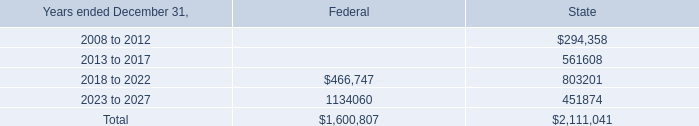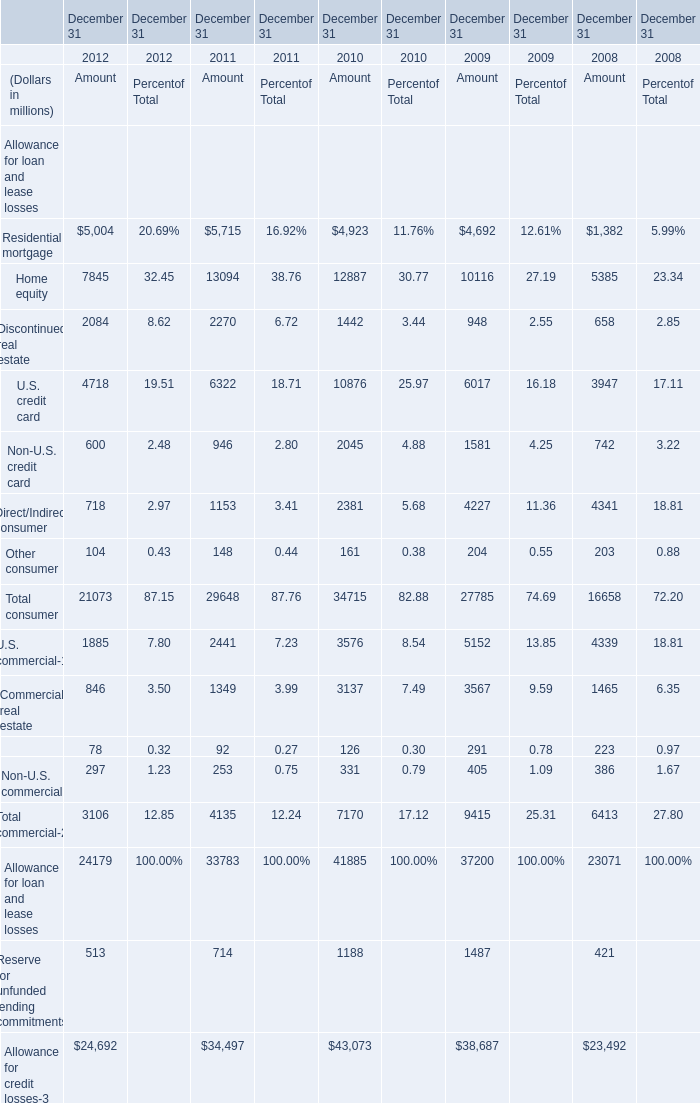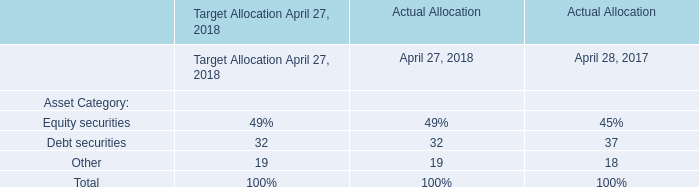what was the change in the total amount of unrecognized tax benefits in 2007in millions? 
Computations: (183.9 - 59.2)
Answer: 124.7. 